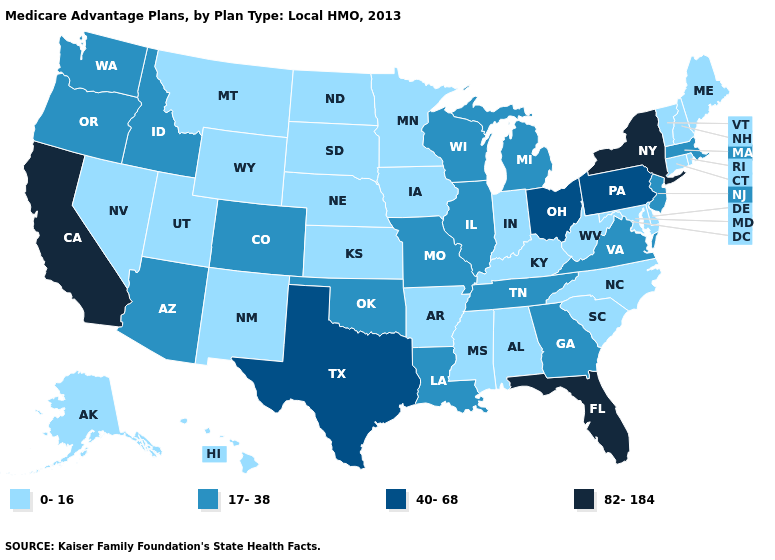What is the value of Alaska?
Be succinct. 0-16. What is the value of Connecticut?
Write a very short answer. 0-16. Does Arkansas have the lowest value in the South?
Short answer required. Yes. Which states have the lowest value in the South?
Quick response, please. Alabama, Arkansas, Delaware, Kentucky, Maryland, Mississippi, North Carolina, South Carolina, West Virginia. What is the value of New Mexico?
Short answer required. 0-16. Among the states that border Missouri , which have the lowest value?
Give a very brief answer. Arkansas, Iowa, Kansas, Kentucky, Nebraska. What is the value of Montana?
Be succinct. 0-16. What is the highest value in the USA?
Short answer required. 82-184. Name the states that have a value in the range 17-38?
Be succinct. Arizona, Colorado, Georgia, Idaho, Illinois, Louisiana, Massachusetts, Michigan, Missouri, New Jersey, Oklahoma, Oregon, Tennessee, Virginia, Washington, Wisconsin. Among the states that border South Dakota , which have the highest value?
Answer briefly. Iowa, Minnesota, Montana, North Dakota, Nebraska, Wyoming. What is the value of Montana?
Answer briefly. 0-16. Which states have the highest value in the USA?
Be succinct. California, Florida, New York. Does California have the highest value in the USA?
Answer briefly. Yes. Does New York have a higher value than South Dakota?
Keep it brief. Yes. Which states have the lowest value in the MidWest?
Concise answer only. Iowa, Indiana, Kansas, Minnesota, North Dakota, Nebraska, South Dakota. 